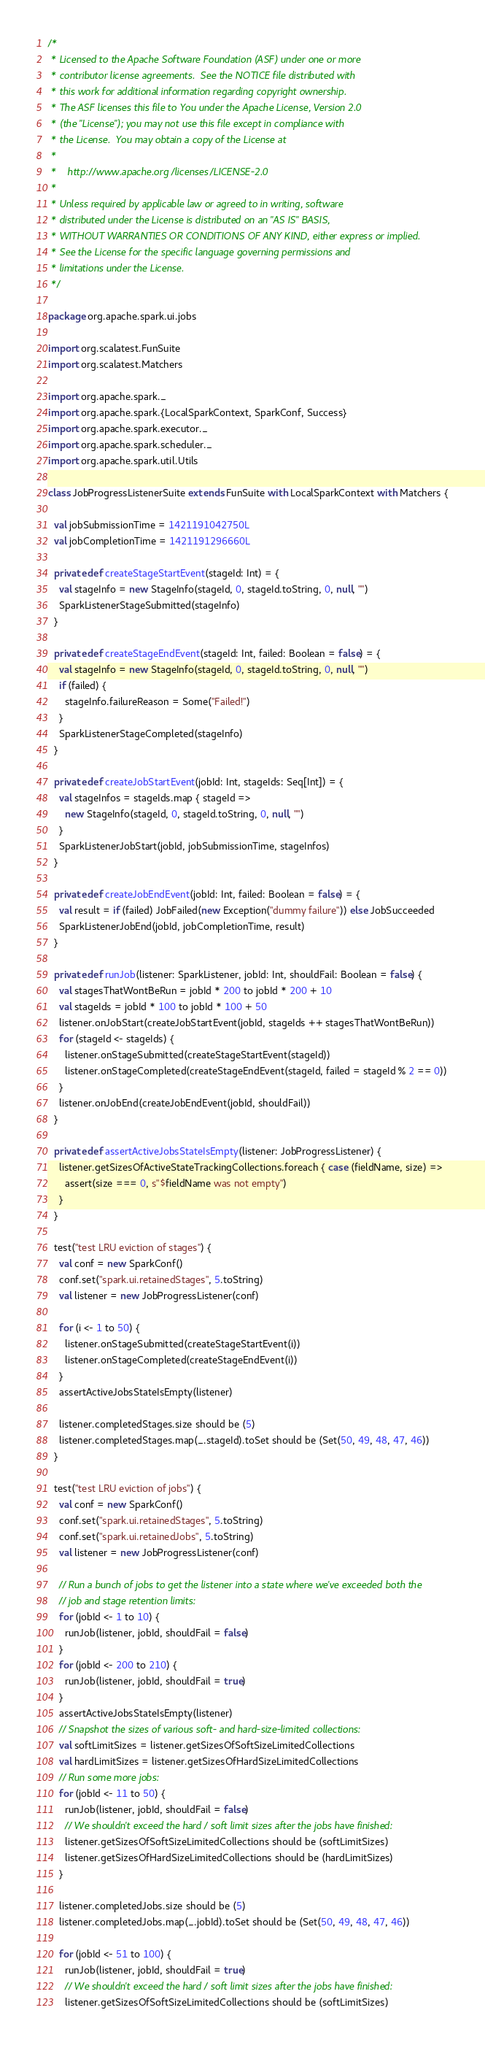Convert code to text. <code><loc_0><loc_0><loc_500><loc_500><_Scala_>/*
 * Licensed to the Apache Software Foundation (ASF) under one or more
 * contributor license agreements.  See the NOTICE file distributed with
 * this work for additional information regarding copyright ownership.
 * The ASF licenses this file to You under the Apache License, Version 2.0
 * (the "License"); you may not use this file except in compliance with
 * the License.  You may obtain a copy of the License at
 *
 *    http://www.apache.org/licenses/LICENSE-2.0
 *
 * Unless required by applicable law or agreed to in writing, software
 * distributed under the License is distributed on an "AS IS" BASIS,
 * WITHOUT WARRANTIES OR CONDITIONS OF ANY KIND, either express or implied.
 * See the License for the specific language governing permissions and
 * limitations under the License.
 */

package org.apache.spark.ui.jobs

import org.scalatest.FunSuite
import org.scalatest.Matchers

import org.apache.spark._
import org.apache.spark.{LocalSparkContext, SparkConf, Success}
import org.apache.spark.executor._
import org.apache.spark.scheduler._
import org.apache.spark.util.Utils

class JobProgressListenerSuite extends FunSuite with LocalSparkContext with Matchers {

  val jobSubmissionTime = 1421191042750L
  val jobCompletionTime = 1421191296660L

  private def createStageStartEvent(stageId: Int) = {
    val stageInfo = new StageInfo(stageId, 0, stageId.toString, 0, null, "")
    SparkListenerStageSubmitted(stageInfo)
  }

  private def createStageEndEvent(stageId: Int, failed: Boolean = false) = {
    val stageInfo = new StageInfo(stageId, 0, stageId.toString, 0, null, "")
    if (failed) {
      stageInfo.failureReason = Some("Failed!")
    }
    SparkListenerStageCompleted(stageInfo)
  }

  private def createJobStartEvent(jobId: Int, stageIds: Seq[Int]) = {
    val stageInfos = stageIds.map { stageId =>
      new StageInfo(stageId, 0, stageId.toString, 0, null, "")
    }
    SparkListenerJobStart(jobId, jobSubmissionTime, stageInfos)
  }

  private def createJobEndEvent(jobId: Int, failed: Boolean = false) = {
    val result = if (failed) JobFailed(new Exception("dummy failure")) else JobSucceeded
    SparkListenerJobEnd(jobId, jobCompletionTime, result)
  }

  private def runJob(listener: SparkListener, jobId: Int, shouldFail: Boolean = false) {
    val stagesThatWontBeRun = jobId * 200 to jobId * 200 + 10
    val stageIds = jobId * 100 to jobId * 100 + 50
    listener.onJobStart(createJobStartEvent(jobId, stageIds ++ stagesThatWontBeRun))
    for (stageId <- stageIds) {
      listener.onStageSubmitted(createStageStartEvent(stageId))
      listener.onStageCompleted(createStageEndEvent(stageId, failed = stageId % 2 == 0))
    }
    listener.onJobEnd(createJobEndEvent(jobId, shouldFail))
  }

  private def assertActiveJobsStateIsEmpty(listener: JobProgressListener) {
    listener.getSizesOfActiveStateTrackingCollections.foreach { case (fieldName, size) =>
      assert(size === 0, s"$fieldName was not empty")
    }
  }

  test("test LRU eviction of stages") {
    val conf = new SparkConf()
    conf.set("spark.ui.retainedStages", 5.toString)
    val listener = new JobProgressListener(conf)

    for (i <- 1 to 50) {
      listener.onStageSubmitted(createStageStartEvent(i))
      listener.onStageCompleted(createStageEndEvent(i))
    }
    assertActiveJobsStateIsEmpty(listener)

    listener.completedStages.size should be (5)
    listener.completedStages.map(_.stageId).toSet should be (Set(50, 49, 48, 47, 46))
  }

  test("test LRU eviction of jobs") {
    val conf = new SparkConf()
    conf.set("spark.ui.retainedStages", 5.toString)
    conf.set("spark.ui.retainedJobs", 5.toString)
    val listener = new JobProgressListener(conf)

    // Run a bunch of jobs to get the listener into a state where we've exceeded both the
    // job and stage retention limits:
    for (jobId <- 1 to 10) {
      runJob(listener, jobId, shouldFail = false)
    }
    for (jobId <- 200 to 210) {
      runJob(listener, jobId, shouldFail = true)
    }
    assertActiveJobsStateIsEmpty(listener)
    // Snapshot the sizes of various soft- and hard-size-limited collections:
    val softLimitSizes = listener.getSizesOfSoftSizeLimitedCollections
    val hardLimitSizes = listener.getSizesOfHardSizeLimitedCollections
    // Run some more jobs:
    for (jobId <- 11 to 50) {
      runJob(listener, jobId, shouldFail = false)
      // We shouldn't exceed the hard / soft limit sizes after the jobs have finished:
      listener.getSizesOfSoftSizeLimitedCollections should be (softLimitSizes)
      listener.getSizesOfHardSizeLimitedCollections should be (hardLimitSizes)
    }

    listener.completedJobs.size should be (5)
    listener.completedJobs.map(_.jobId).toSet should be (Set(50, 49, 48, 47, 46))

    for (jobId <- 51 to 100) {
      runJob(listener, jobId, shouldFail = true)
      // We shouldn't exceed the hard / soft limit sizes after the jobs have finished:
      listener.getSizesOfSoftSizeLimitedCollections should be (softLimitSizes)</code> 